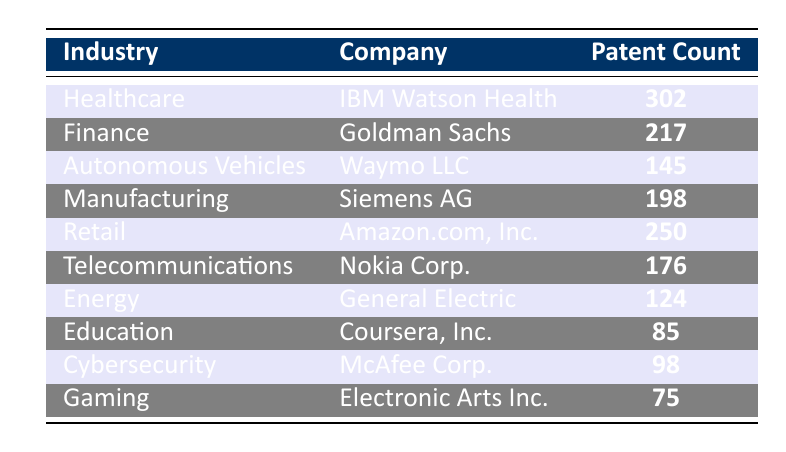What is the total number of patent filings for the Healthcare industry? From the table, we can see that IBM Watson Health filed 302 patents in the Healthcare industry. Therefore, the total number of patent filings for Healthcare is simply 302.
Answer: 302 Which company has the highest patent count? Looking at the table, IBM Watson Health has the highest patent count with 302 filings compared to other companies listed.
Answer: IBM Watson Health How many patent filings did the Retail industry have? The table indicates that Amazon.com, Inc. filed 250 patents in the Retail industry. Thus, the total for Retail is 250.
Answer: 250 What is the average patent count of the Education and Gaming industries? The Education industry has 85 patents (Coursera, Inc.) and the Gaming industry has 75 patents (Electronic Arts Inc.). Adding these gives us 85 + 75 = 160. Dividing by the number of industries (2) gives us an average of 160 / 2 = 80.
Answer: 80 Is the patent count for Goldman Sachs greater than that for General Electric? Goldman Sachs has 217 patents and General Electric has 124. Since 217 is greater than 124, the statement is true.
Answer: Yes What is the difference in patent filings between the Finance and Telecommunications industries? The Finance industry (Goldman Sachs) has 217 patents and the Telecommunications industry (Nokia Corp.) has 176 patents. The difference is 217 - 176 = 41.
Answer: 41 How many companies filed more than 200 patents in 2023? Referring to the table, IBM Watson Health (302), Goldman Sachs (217), and Amazon.com, Inc. (250) filed more than 200 patents. Therefore, there are 3 companies in total.
Answer: 3 What is the combined patent count for the Cybersecurity and Energy industries? The patent count for Cybersecurity (McAfee Corp.) is 98, and for Energy (General Electric) it is 124. Adding these gives a combined total of 98 + 124 = 222.
Answer: 222 Which industry has the least number of patent filings, and what is the count? From the table, the Gaming industry has the least number of patent filings with 75 by Electronic Arts Inc. Therefore, the Gaming industry is the one with the least filings.
Answer: Gaming, 75 If we consider all industries, what is the total number of patent filings? Summing all patent counts from the table gives: 302 + 217 + 145 + 198 + 250 + 176 + 124 + 85 + 98 + 75 = 1,670. Thus, the total number of patent filings is 1,670.
Answer: 1,670 